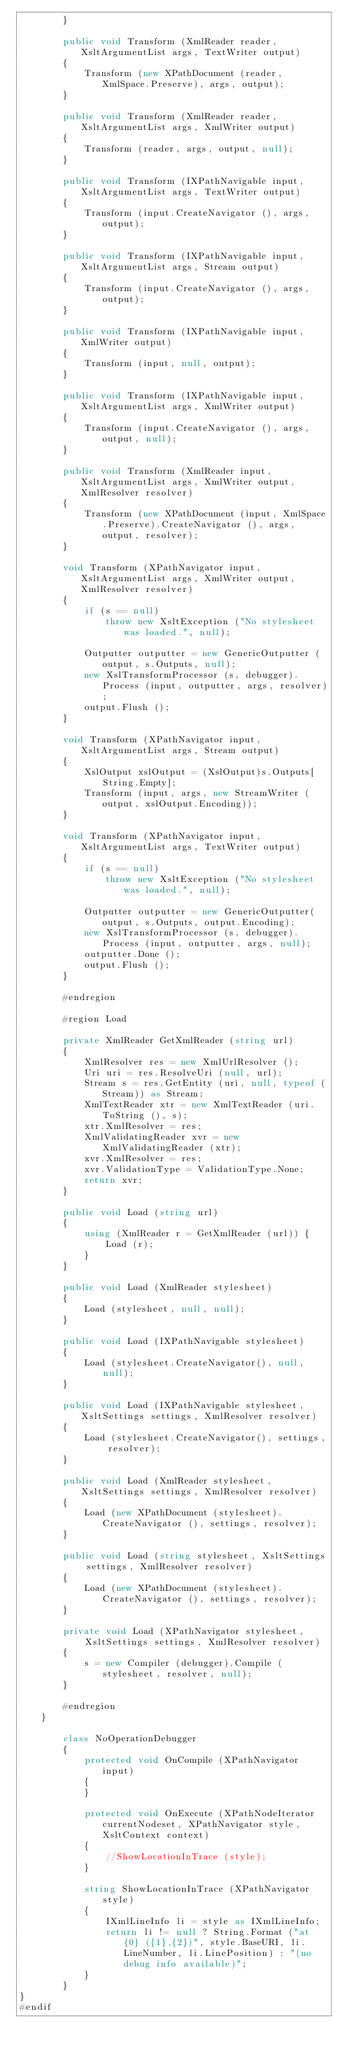Convert code to text. <code><loc_0><loc_0><loc_500><loc_500><_C#_>		}

		public void Transform (XmlReader reader, XsltArgumentList args, TextWriter output)
		{
			Transform (new XPathDocument (reader, XmlSpace.Preserve), args, output);
		}

		public void Transform (XmlReader reader, XsltArgumentList args, XmlWriter output)
		{
			Transform (reader, args, output, null);
		}

		public void Transform (IXPathNavigable input, XsltArgumentList args, TextWriter output)
		{
			Transform (input.CreateNavigator (), args, output);
		}

		public void Transform (IXPathNavigable input, XsltArgumentList args, Stream output)
		{
			Transform (input.CreateNavigator (), args, output);
		}

		public void Transform (IXPathNavigable input, XmlWriter output)
		{
			Transform (input, null, output);
		}

		public void Transform (IXPathNavigable input, XsltArgumentList args, XmlWriter output)
		{
			Transform (input.CreateNavigator (), args, output, null);
		}

		public void Transform (XmlReader input, XsltArgumentList args, XmlWriter output, XmlResolver resolver)
		{
			Transform (new XPathDocument (input, XmlSpace.Preserve).CreateNavigator (), args, output, resolver);
		}

		void Transform (XPathNavigator input, XsltArgumentList args, XmlWriter output, XmlResolver resolver)
		{
			if (s == null)
				throw new XsltException ("No stylesheet was loaded.", null);

			Outputter outputter = new GenericOutputter (output, s.Outputs, null);
			new XslTransformProcessor (s, debugger).Process (input, outputter, args, resolver);
			output.Flush ();
		}

		void Transform (XPathNavigator input, XsltArgumentList args, Stream output)
		{
			XslOutput xslOutput = (XslOutput)s.Outputs[String.Empty];
			Transform (input, args, new StreamWriter (output, xslOutput.Encoding));
		}

		void Transform (XPathNavigator input, XsltArgumentList args, TextWriter output)
		{
			if (s == null)
				throw new XsltException ("No stylesheet was loaded.", null);

			Outputter outputter = new GenericOutputter(output, s.Outputs, output.Encoding);
			new XslTransformProcessor (s, debugger).Process (input, outputter, args, null);
			outputter.Done ();
			output.Flush ();
		}

		#endregion

		#region Load

		private XmlReader GetXmlReader (string url)
		{
			XmlResolver res = new XmlUrlResolver ();
			Uri uri = res.ResolveUri (null, url);
			Stream s = res.GetEntity (uri, null, typeof (Stream)) as Stream;
			XmlTextReader xtr = new XmlTextReader (uri.ToString (), s);
			xtr.XmlResolver = res;
			XmlValidatingReader xvr = new XmlValidatingReader (xtr);
			xvr.XmlResolver = res;
			xvr.ValidationType = ValidationType.None;
			return xvr;
		}

		public void Load (string url)
		{
			using (XmlReader r = GetXmlReader (url)) {
				Load (r);
			}
		}

		public void Load (XmlReader stylesheet)
		{
			Load (stylesheet, null, null);
		}

		public void Load (IXPathNavigable stylesheet)
		{
			Load (stylesheet.CreateNavigator(), null, null);
		}

		public void Load (IXPathNavigable stylesheet, XsltSettings settings, XmlResolver resolver)
		{
			Load (stylesheet.CreateNavigator(), settings, resolver);
		}

		public void Load (XmlReader stylesheet, XsltSettings settings, XmlResolver resolver)
		{
			Load (new XPathDocument (stylesheet).CreateNavigator (), settings, resolver);
		}

		public void Load (string stylesheet, XsltSettings settings, XmlResolver resolver)
		{
			Load (new XPathDocument (stylesheet).CreateNavigator (), settings, resolver);
		}

		private void Load (XPathNavigator stylesheet,
			XsltSettings settings, XmlResolver resolver)
		{
			s = new Compiler (debugger).Compile (stylesheet, resolver, null);
		}

		#endregion
	}

		class NoOperationDebugger
		{
			protected void OnCompile (XPathNavigator input)
			{
			}

			protected void OnExecute (XPathNodeIterator currentNodeset, XPathNavigator style, XsltContext context)
			{
				//ShowLocationInTrace (style);
			}

			string ShowLocationInTrace (XPathNavigator style)
			{
				IXmlLineInfo li = style as IXmlLineInfo;
				return li != null ? String.Format ("at {0} ({1},{2})", style.BaseURI, li.LineNumber, li.LinePosition) : "(no debug info available)";
			}
		}
}
#endif
</code> 